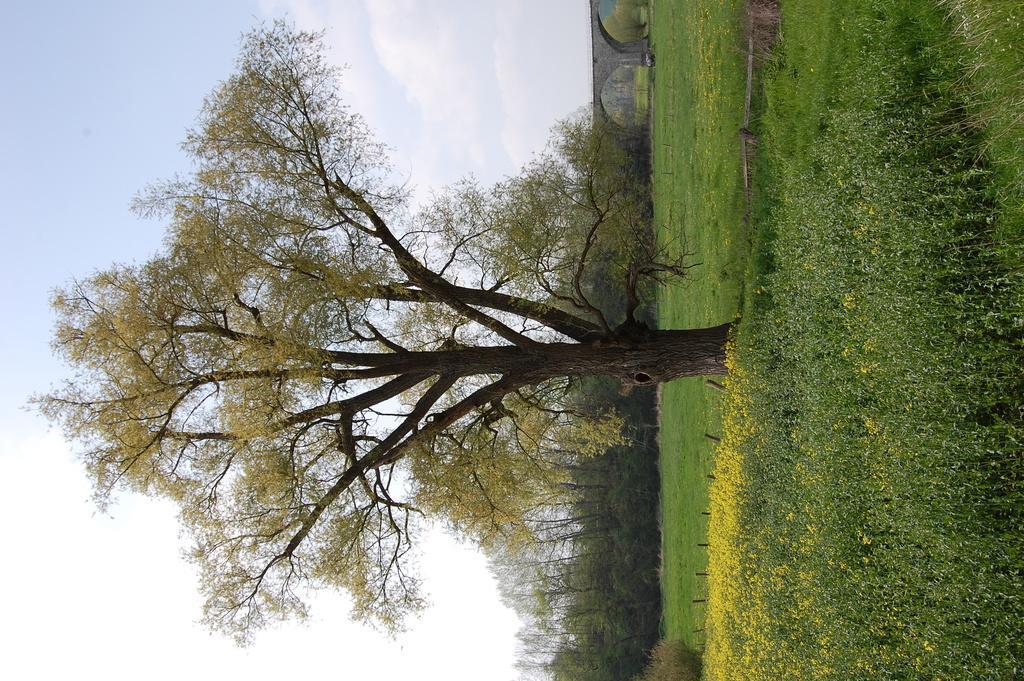Please provide a concise description of this image. In this image on the right side there is grass and some plants and flowers, and in the center there is a tree. And in the background there are some trees and bridge, and on the left side of the image there is sky. 